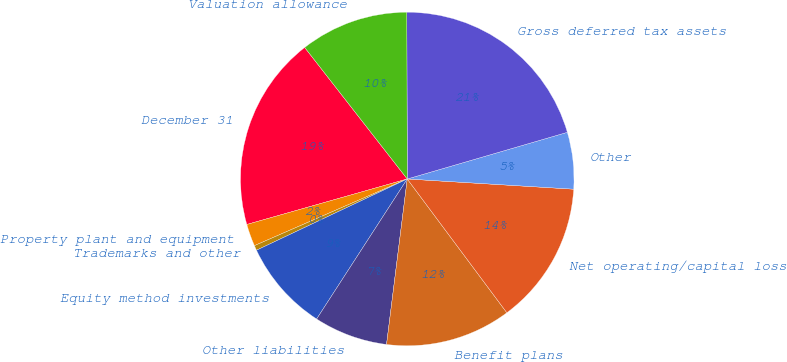Convert chart to OTSL. <chart><loc_0><loc_0><loc_500><loc_500><pie_chart><fcel>December 31<fcel>Property plant and equipment<fcel>Trademarks and other<fcel>Equity method investments<fcel>Other liabilities<fcel>Benefit plans<fcel>Net operating/capital loss<fcel>Other<fcel>Gross deferred tax assets<fcel>Valuation allowance<nl><fcel>18.86%<fcel>2.15%<fcel>0.48%<fcel>8.83%<fcel>7.16%<fcel>12.17%<fcel>13.84%<fcel>5.49%<fcel>20.53%<fcel>10.5%<nl></chart> 